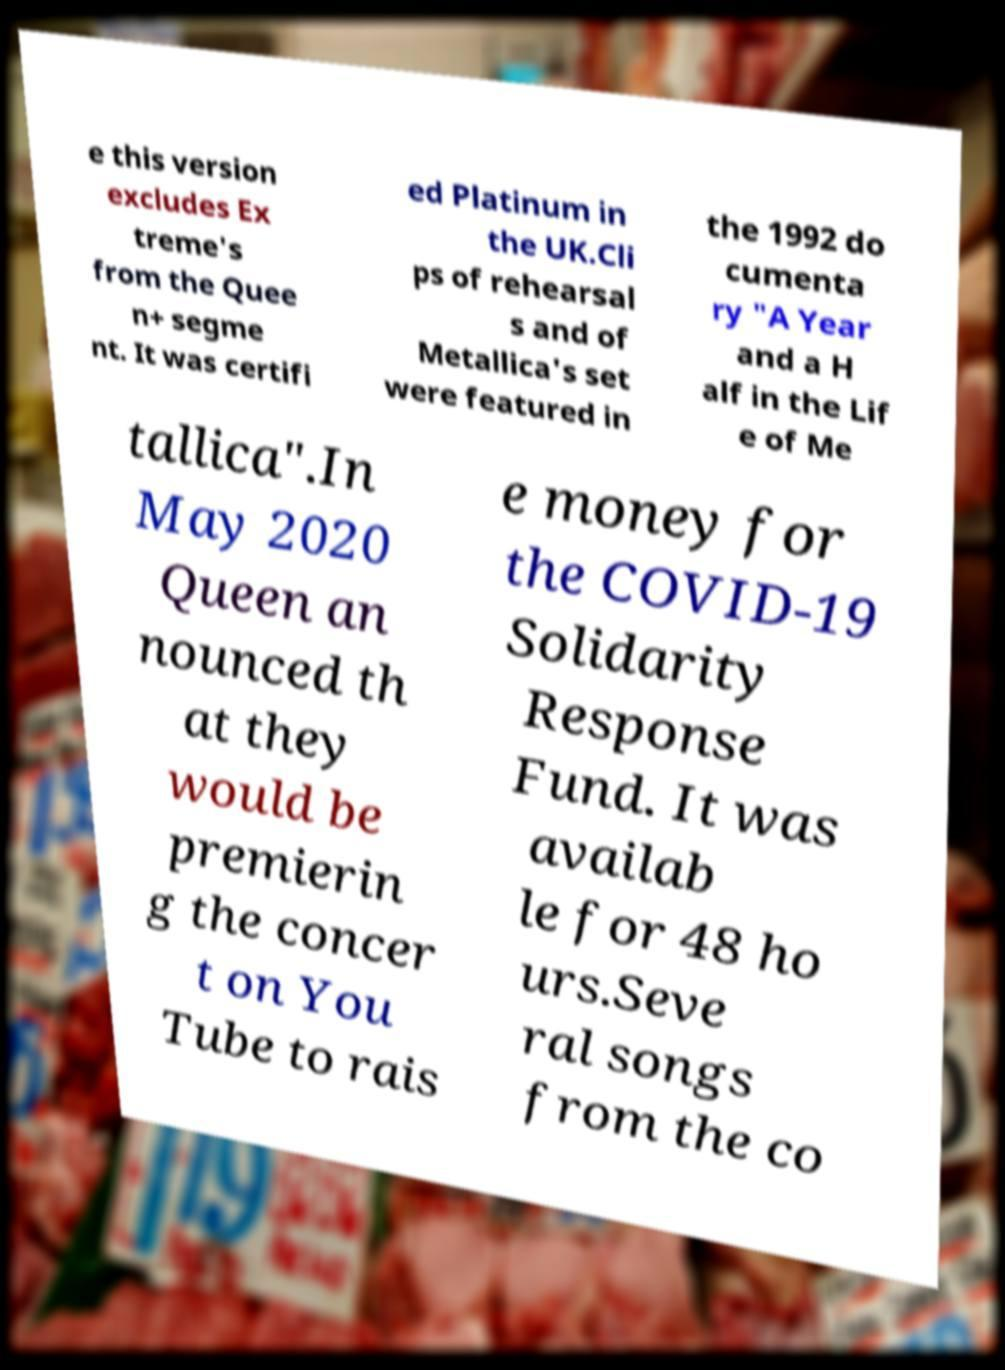What messages or text are displayed in this image? I need them in a readable, typed format. e this version excludes Ex treme's from the Quee n+ segme nt. It was certifi ed Platinum in the UK.Cli ps of rehearsal s and of Metallica's set were featured in the 1992 do cumenta ry "A Year and a H alf in the Lif e of Me tallica".In May 2020 Queen an nounced th at they would be premierin g the concer t on You Tube to rais e money for the COVID-19 Solidarity Response Fund. It was availab le for 48 ho urs.Seve ral songs from the co 